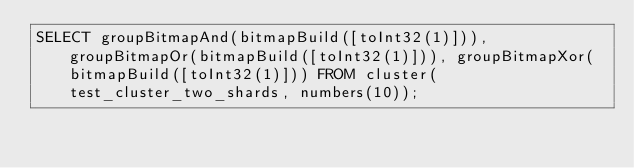Convert code to text. <code><loc_0><loc_0><loc_500><loc_500><_SQL_>SELECT groupBitmapAnd(bitmapBuild([toInt32(1)])), groupBitmapOr(bitmapBuild([toInt32(1)])), groupBitmapXor(bitmapBuild([toInt32(1)])) FROM cluster(test_cluster_two_shards, numbers(10));
</code> 